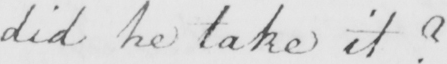Please provide the text content of this handwritten line. did he take it ? 